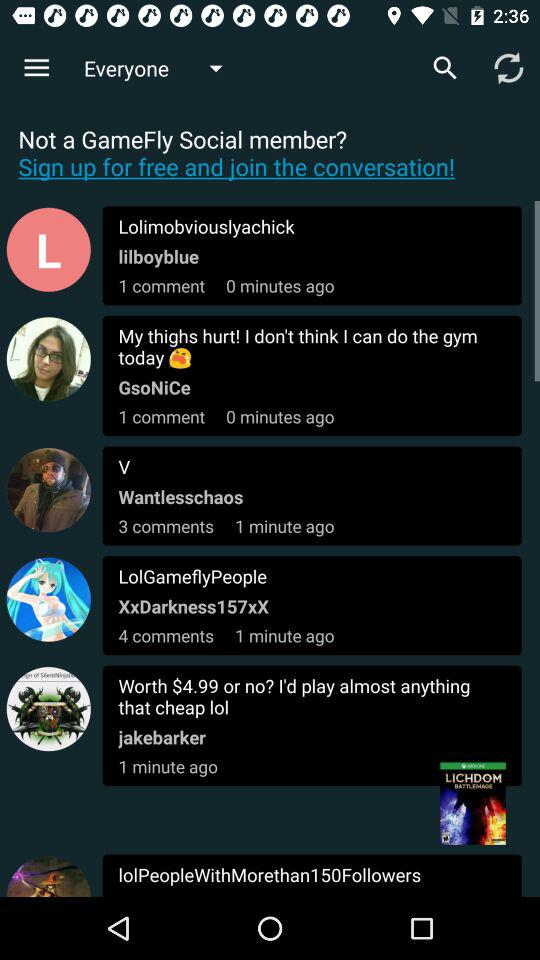How many more comments does the most commented post have than the least commented post?
Answer the question using a single word or phrase. 3 